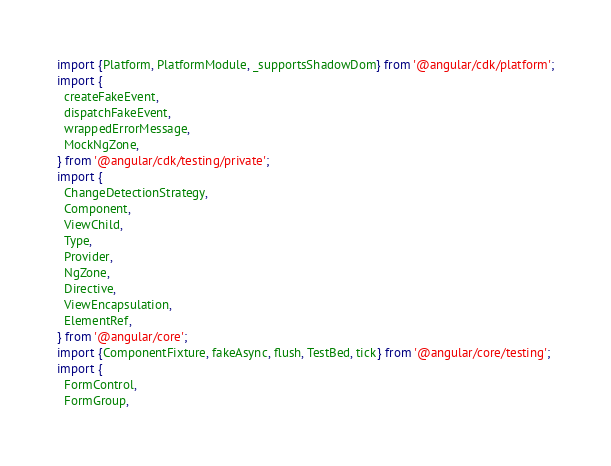<code> <loc_0><loc_0><loc_500><loc_500><_TypeScript_>import {Platform, PlatformModule, _supportsShadowDom} from '@angular/cdk/platform';
import {
  createFakeEvent,
  dispatchFakeEvent,
  wrappedErrorMessage,
  MockNgZone,
} from '@angular/cdk/testing/private';
import {
  ChangeDetectionStrategy,
  Component,
  ViewChild,
  Type,
  Provider,
  NgZone,
  Directive,
  ViewEncapsulation,
  ElementRef,
} from '@angular/core';
import {ComponentFixture, fakeAsync, flush, TestBed, tick} from '@angular/core/testing';
import {
  FormControl,
  FormGroup,</code> 